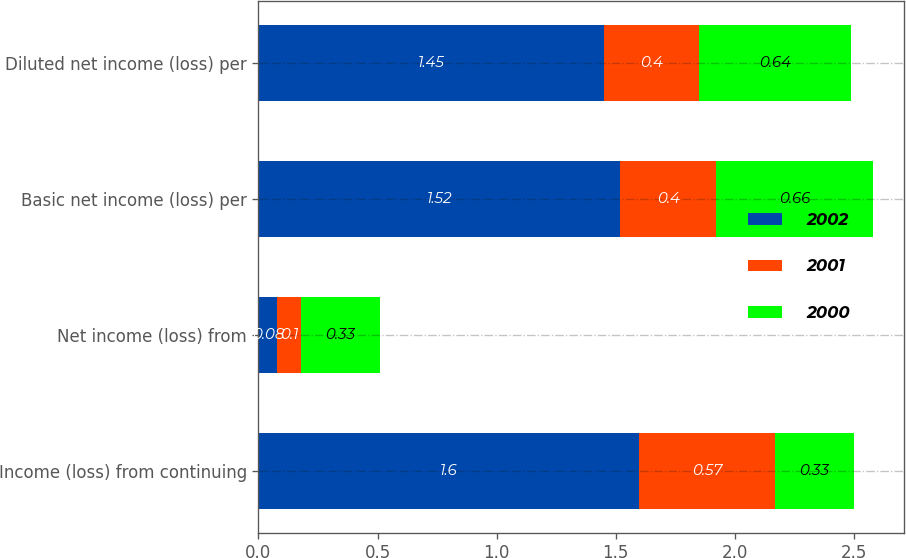<chart> <loc_0><loc_0><loc_500><loc_500><stacked_bar_chart><ecel><fcel>Income (loss) from continuing<fcel>Net income (loss) from<fcel>Basic net income (loss) per<fcel>Diluted net income (loss) per<nl><fcel>2002<fcel>1.6<fcel>0.08<fcel>1.52<fcel>1.45<nl><fcel>2001<fcel>0.57<fcel>0.1<fcel>0.4<fcel>0.4<nl><fcel>2000<fcel>0.33<fcel>0.33<fcel>0.66<fcel>0.64<nl></chart> 